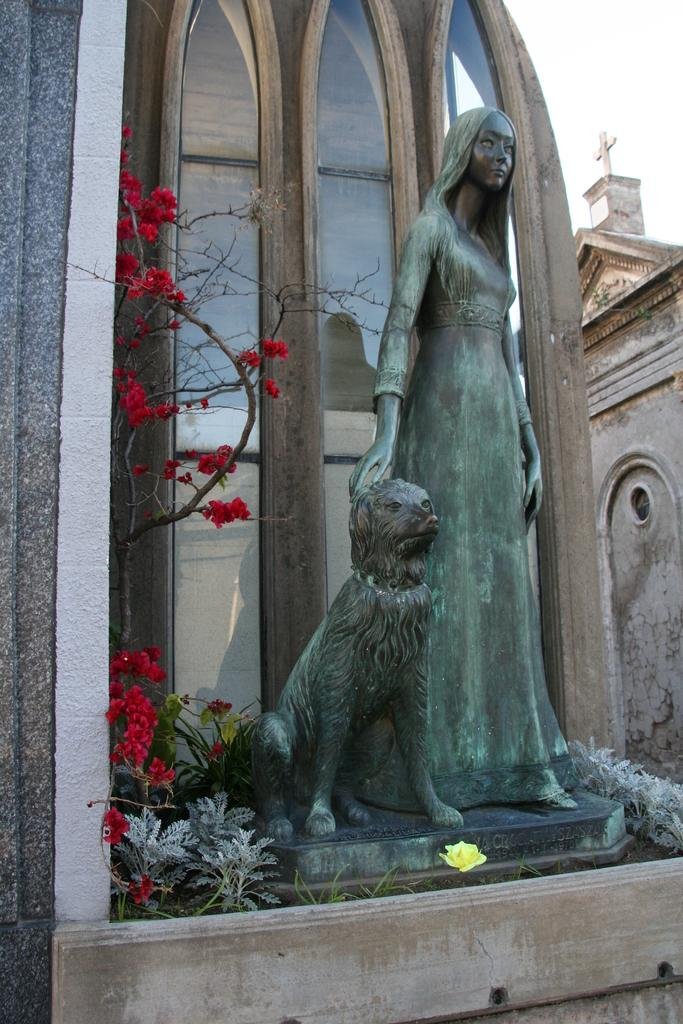What is the main subject in the center of the image? There is a statue of a woman and an animal in the center of the image. What can be seen in the background of the image? There are buildings in the background of the image. What type of vegetation is present in the image? There is a plant in the image. What is visible at the top of the image? The sky is visible at the top of the image. What type of invention is being demonstrated by the statue in the image? The statue does not demonstrate any invention; it is a static representation of a woman and an animal. Can you hear a whistle in the image? There is no whistle present in the image, as it is a visual medium. 